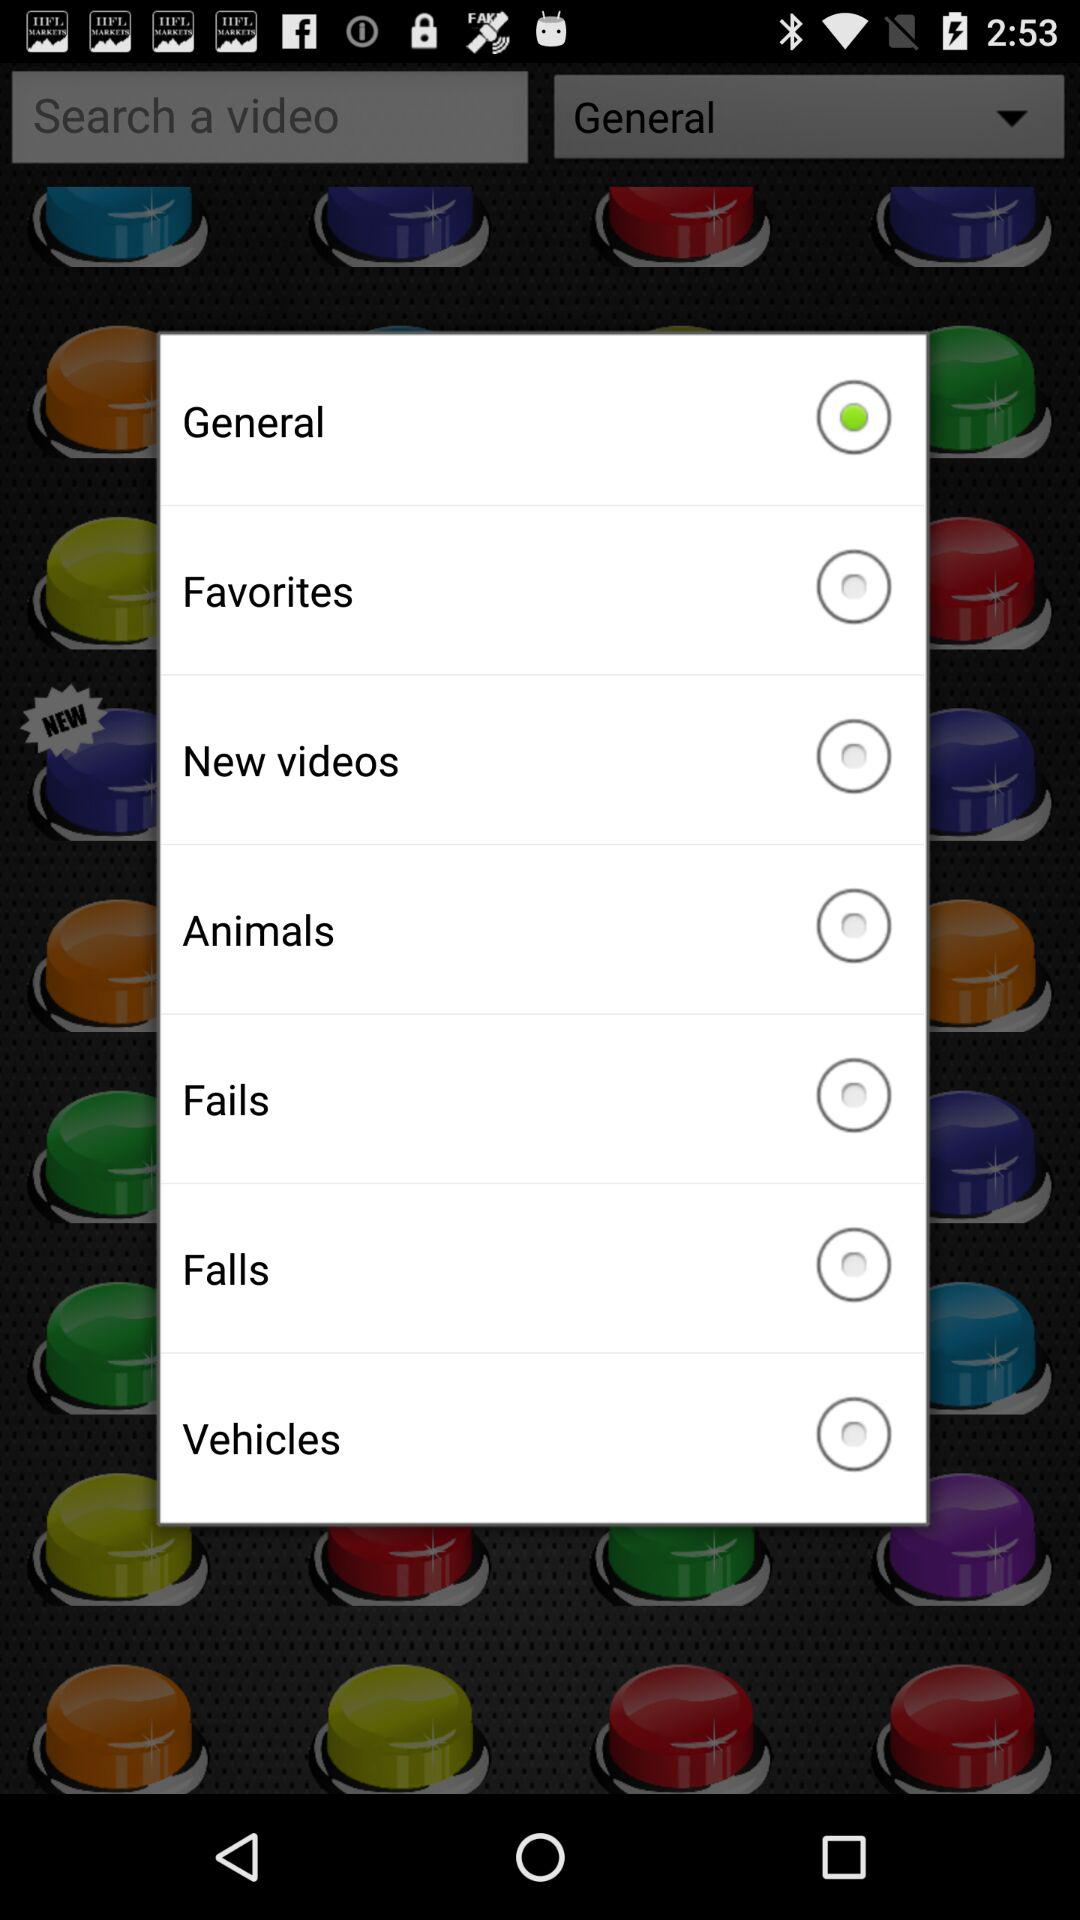Which option is selected? The selected option is "General". 